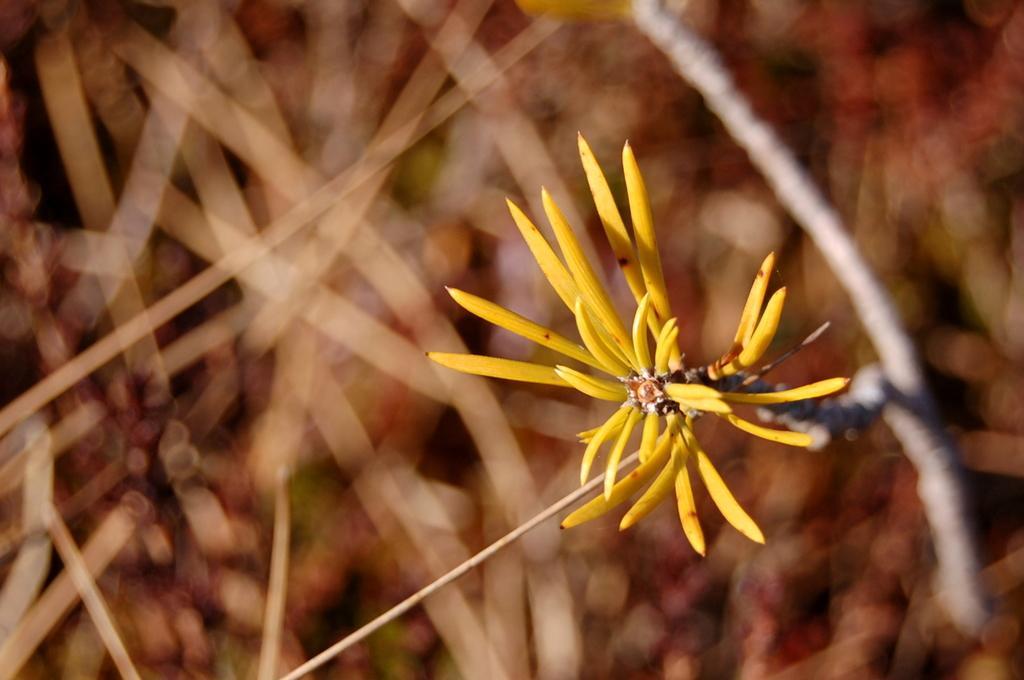Can you describe this image briefly? In this image I can see a yellow colour flower and few sticks in the front. In the background I can see number of brown colour things and I can also see this image is little bit blurry. 